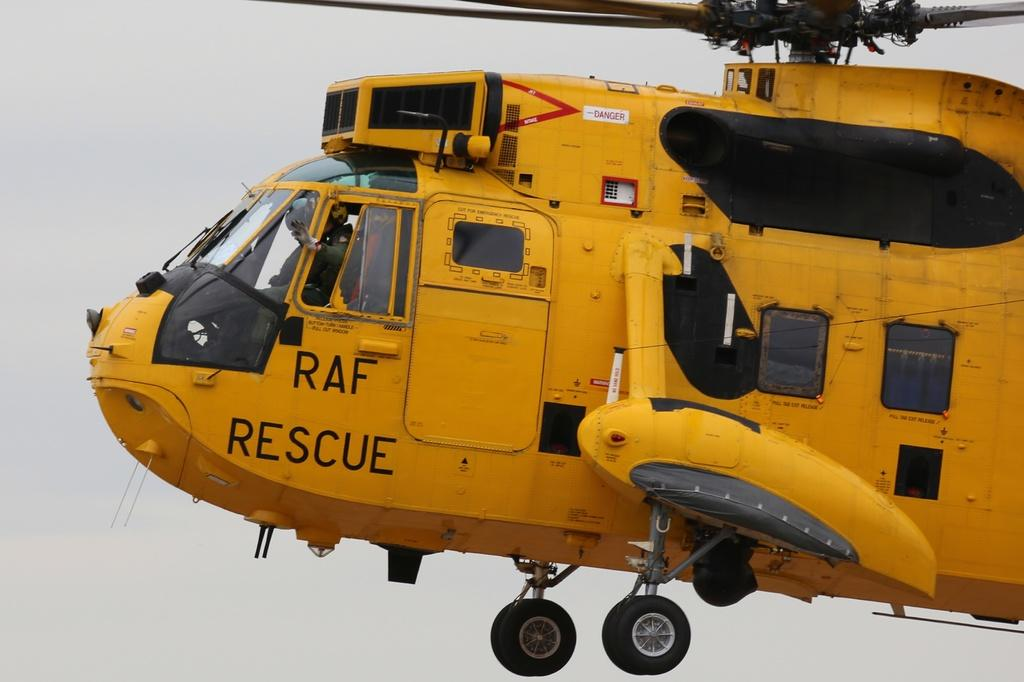What type of vehicle is in the image? There is a yellow helicopter in the image. What is the helicopter doing in the image? The helicopter is flying in the air. Are there any passengers in the helicopter? Yes, there are people inside the helicopter. What can be seen in the background of the image? The sky is visible in the background of the image. Where is the ticket booth located in the image? There is no ticket booth present in the image; it features a yellow helicopter flying in the air. What type of animals can be seen on the farm in the image? There is no farm present in the image; it features a yellow helicopter flying in the air. 